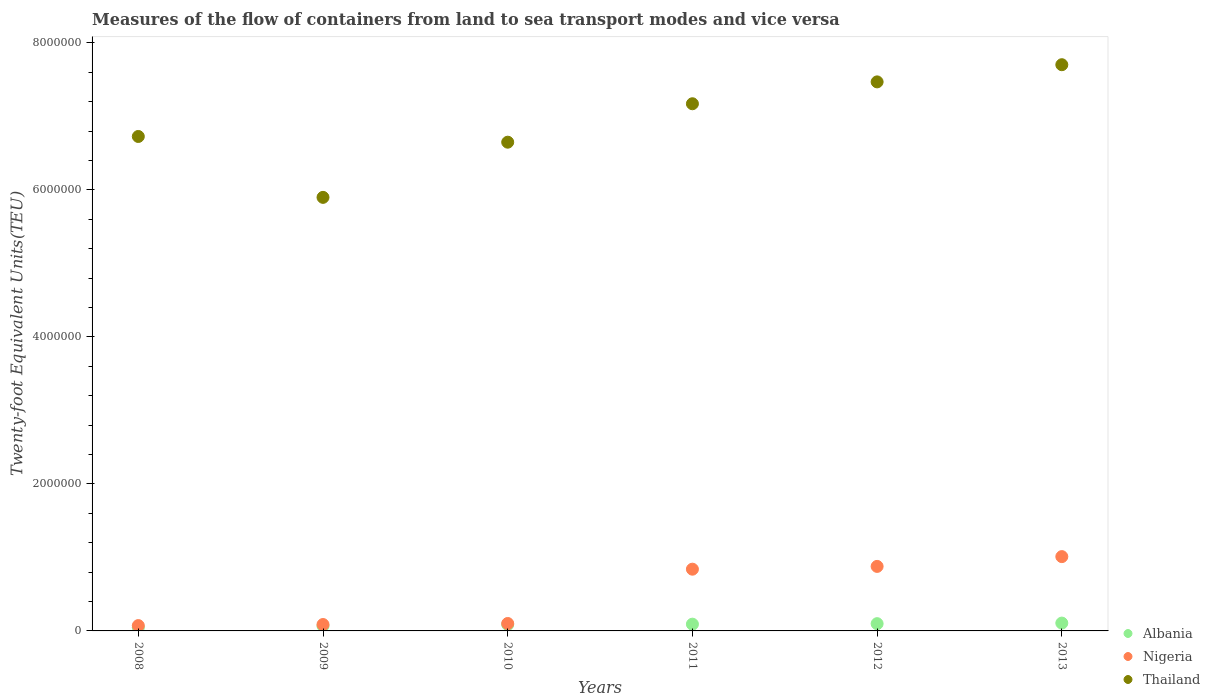How many different coloured dotlines are there?
Provide a succinct answer. 3. What is the container port traffic in Nigeria in 2010?
Keep it short and to the point. 1.01e+05. Across all years, what is the maximum container port traffic in Thailand?
Give a very brief answer. 7.70e+06. Across all years, what is the minimum container port traffic in Thailand?
Your answer should be very brief. 5.90e+06. In which year was the container port traffic in Albania maximum?
Provide a short and direct response. 2013. What is the total container port traffic in Albania in the graph?
Give a very brief answer. 5.00e+05. What is the difference between the container port traffic in Albania in 2008 and that in 2010?
Provide a short and direct response. -4.01e+04. What is the difference between the container port traffic in Thailand in 2011 and the container port traffic in Albania in 2008?
Offer a terse response. 7.12e+06. What is the average container port traffic in Thailand per year?
Offer a very short reply. 6.94e+06. In the year 2008, what is the difference between the container port traffic in Thailand and container port traffic in Albania?
Your answer should be compact. 6.68e+06. What is the ratio of the container port traffic in Albania in 2008 to that in 2012?
Give a very brief answer. 0.47. Is the difference between the container port traffic in Thailand in 2008 and 2010 greater than the difference between the container port traffic in Albania in 2008 and 2010?
Offer a very short reply. Yes. What is the difference between the highest and the second highest container port traffic in Nigeria?
Ensure brevity in your answer.  1.33e+05. What is the difference between the highest and the lowest container port traffic in Nigeria?
Your answer should be very brief. 9.38e+05. Is the sum of the container port traffic in Thailand in 2010 and 2011 greater than the maximum container port traffic in Nigeria across all years?
Your answer should be very brief. Yes. Is it the case that in every year, the sum of the container port traffic in Albania and container port traffic in Nigeria  is greater than the container port traffic in Thailand?
Offer a very short reply. No. Is the container port traffic in Nigeria strictly greater than the container port traffic in Thailand over the years?
Make the answer very short. No. How many dotlines are there?
Ensure brevity in your answer.  3. How many years are there in the graph?
Provide a short and direct response. 6. Does the graph contain any zero values?
Offer a very short reply. No. Does the graph contain grids?
Offer a very short reply. No. What is the title of the graph?
Your answer should be very brief. Measures of the flow of containers from land to sea transport modes and vice versa. What is the label or title of the X-axis?
Give a very brief answer. Years. What is the label or title of the Y-axis?
Offer a terse response. Twenty-foot Equivalent Units(TEU). What is the Twenty-foot Equivalent Units(TEU) of Albania in 2008?
Offer a very short reply. 4.68e+04. What is the Twenty-foot Equivalent Units(TEU) in Nigeria in 2008?
Provide a succinct answer. 7.25e+04. What is the Twenty-foot Equivalent Units(TEU) in Thailand in 2008?
Your answer should be very brief. 6.73e+06. What is the Twenty-foot Equivalent Units(TEU) in Albania in 2009?
Provide a succinct answer. 6.88e+04. What is the Twenty-foot Equivalent Units(TEU) of Nigeria in 2009?
Give a very brief answer. 8.70e+04. What is the Twenty-foot Equivalent Units(TEU) in Thailand in 2009?
Provide a succinct answer. 5.90e+06. What is the Twenty-foot Equivalent Units(TEU) of Albania in 2010?
Make the answer very short. 8.69e+04. What is the Twenty-foot Equivalent Units(TEU) in Nigeria in 2010?
Your response must be concise. 1.01e+05. What is the Twenty-foot Equivalent Units(TEU) in Thailand in 2010?
Ensure brevity in your answer.  6.65e+06. What is the Twenty-foot Equivalent Units(TEU) in Albania in 2011?
Your answer should be compact. 9.18e+04. What is the Twenty-foot Equivalent Units(TEU) in Nigeria in 2011?
Your answer should be very brief. 8.40e+05. What is the Twenty-foot Equivalent Units(TEU) in Thailand in 2011?
Offer a very short reply. 7.17e+06. What is the Twenty-foot Equivalent Units(TEU) in Albania in 2012?
Ensure brevity in your answer.  9.87e+04. What is the Twenty-foot Equivalent Units(TEU) in Nigeria in 2012?
Your answer should be very brief. 8.78e+05. What is the Twenty-foot Equivalent Units(TEU) of Thailand in 2012?
Your answer should be very brief. 7.47e+06. What is the Twenty-foot Equivalent Units(TEU) of Albania in 2013?
Offer a very short reply. 1.07e+05. What is the Twenty-foot Equivalent Units(TEU) in Nigeria in 2013?
Provide a succinct answer. 1.01e+06. What is the Twenty-foot Equivalent Units(TEU) in Thailand in 2013?
Ensure brevity in your answer.  7.70e+06. Across all years, what is the maximum Twenty-foot Equivalent Units(TEU) of Albania?
Offer a very short reply. 1.07e+05. Across all years, what is the maximum Twenty-foot Equivalent Units(TEU) in Nigeria?
Keep it short and to the point. 1.01e+06. Across all years, what is the maximum Twenty-foot Equivalent Units(TEU) in Thailand?
Offer a terse response. 7.70e+06. Across all years, what is the minimum Twenty-foot Equivalent Units(TEU) of Albania?
Give a very brief answer. 4.68e+04. Across all years, what is the minimum Twenty-foot Equivalent Units(TEU) of Nigeria?
Your answer should be very brief. 7.25e+04. Across all years, what is the minimum Twenty-foot Equivalent Units(TEU) of Thailand?
Your answer should be very brief. 5.90e+06. What is the total Twenty-foot Equivalent Units(TEU) of Albania in the graph?
Your answer should be compact. 5.00e+05. What is the total Twenty-foot Equivalent Units(TEU) in Nigeria in the graph?
Your answer should be compact. 2.99e+06. What is the total Twenty-foot Equivalent Units(TEU) of Thailand in the graph?
Make the answer very short. 4.16e+07. What is the difference between the Twenty-foot Equivalent Units(TEU) in Albania in 2008 and that in 2009?
Keep it short and to the point. -2.20e+04. What is the difference between the Twenty-foot Equivalent Units(TEU) in Nigeria in 2008 and that in 2009?
Give a very brief answer. -1.45e+04. What is the difference between the Twenty-foot Equivalent Units(TEU) of Thailand in 2008 and that in 2009?
Ensure brevity in your answer.  8.28e+05. What is the difference between the Twenty-foot Equivalent Units(TEU) of Albania in 2008 and that in 2010?
Make the answer very short. -4.01e+04. What is the difference between the Twenty-foot Equivalent Units(TEU) in Nigeria in 2008 and that in 2010?
Ensure brevity in your answer.  -2.85e+04. What is the difference between the Twenty-foot Equivalent Units(TEU) in Thailand in 2008 and that in 2010?
Your answer should be very brief. 7.77e+04. What is the difference between the Twenty-foot Equivalent Units(TEU) of Albania in 2008 and that in 2011?
Keep it short and to the point. -4.50e+04. What is the difference between the Twenty-foot Equivalent Units(TEU) in Nigeria in 2008 and that in 2011?
Your answer should be compact. -7.67e+05. What is the difference between the Twenty-foot Equivalent Units(TEU) in Thailand in 2008 and that in 2011?
Provide a short and direct response. -4.45e+05. What is the difference between the Twenty-foot Equivalent Units(TEU) of Albania in 2008 and that in 2012?
Provide a short and direct response. -5.19e+04. What is the difference between the Twenty-foot Equivalent Units(TEU) of Nigeria in 2008 and that in 2012?
Make the answer very short. -8.05e+05. What is the difference between the Twenty-foot Equivalent Units(TEU) of Thailand in 2008 and that in 2012?
Your answer should be compact. -7.43e+05. What is the difference between the Twenty-foot Equivalent Units(TEU) in Albania in 2008 and that in 2013?
Give a very brief answer. -5.97e+04. What is the difference between the Twenty-foot Equivalent Units(TEU) of Nigeria in 2008 and that in 2013?
Keep it short and to the point. -9.38e+05. What is the difference between the Twenty-foot Equivalent Units(TEU) of Thailand in 2008 and that in 2013?
Keep it short and to the point. -9.76e+05. What is the difference between the Twenty-foot Equivalent Units(TEU) of Albania in 2009 and that in 2010?
Provide a short and direct response. -1.81e+04. What is the difference between the Twenty-foot Equivalent Units(TEU) of Nigeria in 2009 and that in 2010?
Your answer should be compact. -1.40e+04. What is the difference between the Twenty-foot Equivalent Units(TEU) of Thailand in 2009 and that in 2010?
Provide a short and direct response. -7.51e+05. What is the difference between the Twenty-foot Equivalent Units(TEU) in Albania in 2009 and that in 2011?
Give a very brief answer. -2.30e+04. What is the difference between the Twenty-foot Equivalent Units(TEU) in Nigeria in 2009 and that in 2011?
Your answer should be very brief. -7.53e+05. What is the difference between the Twenty-foot Equivalent Units(TEU) of Thailand in 2009 and that in 2011?
Offer a very short reply. -1.27e+06. What is the difference between the Twenty-foot Equivalent Units(TEU) in Albania in 2009 and that in 2012?
Provide a succinct answer. -2.99e+04. What is the difference between the Twenty-foot Equivalent Units(TEU) of Nigeria in 2009 and that in 2012?
Your answer should be very brief. -7.91e+05. What is the difference between the Twenty-foot Equivalent Units(TEU) in Thailand in 2009 and that in 2012?
Make the answer very short. -1.57e+06. What is the difference between the Twenty-foot Equivalent Units(TEU) of Albania in 2009 and that in 2013?
Ensure brevity in your answer.  -3.77e+04. What is the difference between the Twenty-foot Equivalent Units(TEU) in Nigeria in 2009 and that in 2013?
Provide a short and direct response. -9.24e+05. What is the difference between the Twenty-foot Equivalent Units(TEU) of Thailand in 2009 and that in 2013?
Your answer should be very brief. -1.80e+06. What is the difference between the Twenty-foot Equivalent Units(TEU) in Albania in 2010 and that in 2011?
Your answer should be compact. -4951.88. What is the difference between the Twenty-foot Equivalent Units(TEU) in Nigeria in 2010 and that in 2011?
Your answer should be very brief. -7.39e+05. What is the difference between the Twenty-foot Equivalent Units(TEU) in Thailand in 2010 and that in 2011?
Ensure brevity in your answer.  -5.23e+05. What is the difference between the Twenty-foot Equivalent Units(TEU) of Albania in 2010 and that in 2012?
Your answer should be very brief. -1.18e+04. What is the difference between the Twenty-foot Equivalent Units(TEU) in Nigeria in 2010 and that in 2012?
Your response must be concise. -7.77e+05. What is the difference between the Twenty-foot Equivalent Units(TEU) in Thailand in 2010 and that in 2012?
Your response must be concise. -8.20e+05. What is the difference between the Twenty-foot Equivalent Units(TEU) of Albania in 2010 and that in 2013?
Your answer should be compact. -1.96e+04. What is the difference between the Twenty-foot Equivalent Units(TEU) in Nigeria in 2010 and that in 2013?
Offer a very short reply. -9.10e+05. What is the difference between the Twenty-foot Equivalent Units(TEU) in Thailand in 2010 and that in 2013?
Ensure brevity in your answer.  -1.05e+06. What is the difference between the Twenty-foot Equivalent Units(TEU) of Albania in 2011 and that in 2012?
Offer a terse response. -6887.02. What is the difference between the Twenty-foot Equivalent Units(TEU) in Nigeria in 2011 and that in 2012?
Keep it short and to the point. -3.78e+04. What is the difference between the Twenty-foot Equivalent Units(TEU) in Thailand in 2011 and that in 2012?
Your response must be concise. -2.98e+05. What is the difference between the Twenty-foot Equivalent Units(TEU) of Albania in 2011 and that in 2013?
Offer a very short reply. -1.47e+04. What is the difference between the Twenty-foot Equivalent Units(TEU) of Nigeria in 2011 and that in 2013?
Your answer should be very brief. -1.71e+05. What is the difference between the Twenty-foot Equivalent Units(TEU) in Thailand in 2011 and that in 2013?
Provide a short and direct response. -5.31e+05. What is the difference between the Twenty-foot Equivalent Units(TEU) in Albania in 2012 and that in 2013?
Provide a succinct answer. -7798.4. What is the difference between the Twenty-foot Equivalent Units(TEU) in Nigeria in 2012 and that in 2013?
Provide a short and direct response. -1.33e+05. What is the difference between the Twenty-foot Equivalent Units(TEU) in Thailand in 2012 and that in 2013?
Provide a succinct answer. -2.34e+05. What is the difference between the Twenty-foot Equivalent Units(TEU) in Albania in 2008 and the Twenty-foot Equivalent Units(TEU) in Nigeria in 2009?
Give a very brief answer. -4.02e+04. What is the difference between the Twenty-foot Equivalent Units(TEU) of Albania in 2008 and the Twenty-foot Equivalent Units(TEU) of Thailand in 2009?
Provide a succinct answer. -5.85e+06. What is the difference between the Twenty-foot Equivalent Units(TEU) in Nigeria in 2008 and the Twenty-foot Equivalent Units(TEU) in Thailand in 2009?
Your response must be concise. -5.83e+06. What is the difference between the Twenty-foot Equivalent Units(TEU) in Albania in 2008 and the Twenty-foot Equivalent Units(TEU) in Nigeria in 2010?
Provide a succinct answer. -5.42e+04. What is the difference between the Twenty-foot Equivalent Units(TEU) in Albania in 2008 and the Twenty-foot Equivalent Units(TEU) in Thailand in 2010?
Your answer should be very brief. -6.60e+06. What is the difference between the Twenty-foot Equivalent Units(TEU) in Nigeria in 2008 and the Twenty-foot Equivalent Units(TEU) in Thailand in 2010?
Offer a terse response. -6.58e+06. What is the difference between the Twenty-foot Equivalent Units(TEU) in Albania in 2008 and the Twenty-foot Equivalent Units(TEU) in Nigeria in 2011?
Provide a short and direct response. -7.93e+05. What is the difference between the Twenty-foot Equivalent Units(TEU) in Albania in 2008 and the Twenty-foot Equivalent Units(TEU) in Thailand in 2011?
Make the answer very short. -7.12e+06. What is the difference between the Twenty-foot Equivalent Units(TEU) of Nigeria in 2008 and the Twenty-foot Equivalent Units(TEU) of Thailand in 2011?
Your response must be concise. -7.10e+06. What is the difference between the Twenty-foot Equivalent Units(TEU) in Albania in 2008 and the Twenty-foot Equivalent Units(TEU) in Nigeria in 2012?
Your answer should be compact. -8.31e+05. What is the difference between the Twenty-foot Equivalent Units(TEU) of Albania in 2008 and the Twenty-foot Equivalent Units(TEU) of Thailand in 2012?
Your answer should be very brief. -7.42e+06. What is the difference between the Twenty-foot Equivalent Units(TEU) of Nigeria in 2008 and the Twenty-foot Equivalent Units(TEU) of Thailand in 2012?
Offer a terse response. -7.40e+06. What is the difference between the Twenty-foot Equivalent Units(TEU) of Albania in 2008 and the Twenty-foot Equivalent Units(TEU) of Nigeria in 2013?
Your answer should be very brief. -9.64e+05. What is the difference between the Twenty-foot Equivalent Units(TEU) in Albania in 2008 and the Twenty-foot Equivalent Units(TEU) in Thailand in 2013?
Make the answer very short. -7.66e+06. What is the difference between the Twenty-foot Equivalent Units(TEU) in Nigeria in 2008 and the Twenty-foot Equivalent Units(TEU) in Thailand in 2013?
Give a very brief answer. -7.63e+06. What is the difference between the Twenty-foot Equivalent Units(TEU) in Albania in 2009 and the Twenty-foot Equivalent Units(TEU) in Nigeria in 2010?
Give a very brief answer. -3.22e+04. What is the difference between the Twenty-foot Equivalent Units(TEU) in Albania in 2009 and the Twenty-foot Equivalent Units(TEU) in Thailand in 2010?
Offer a terse response. -6.58e+06. What is the difference between the Twenty-foot Equivalent Units(TEU) of Nigeria in 2009 and the Twenty-foot Equivalent Units(TEU) of Thailand in 2010?
Offer a terse response. -6.56e+06. What is the difference between the Twenty-foot Equivalent Units(TEU) in Albania in 2009 and the Twenty-foot Equivalent Units(TEU) in Nigeria in 2011?
Keep it short and to the point. -7.71e+05. What is the difference between the Twenty-foot Equivalent Units(TEU) in Albania in 2009 and the Twenty-foot Equivalent Units(TEU) in Thailand in 2011?
Offer a terse response. -7.10e+06. What is the difference between the Twenty-foot Equivalent Units(TEU) of Nigeria in 2009 and the Twenty-foot Equivalent Units(TEU) of Thailand in 2011?
Your answer should be compact. -7.08e+06. What is the difference between the Twenty-foot Equivalent Units(TEU) in Albania in 2009 and the Twenty-foot Equivalent Units(TEU) in Nigeria in 2012?
Provide a short and direct response. -8.09e+05. What is the difference between the Twenty-foot Equivalent Units(TEU) of Albania in 2009 and the Twenty-foot Equivalent Units(TEU) of Thailand in 2012?
Offer a very short reply. -7.40e+06. What is the difference between the Twenty-foot Equivalent Units(TEU) in Nigeria in 2009 and the Twenty-foot Equivalent Units(TEU) in Thailand in 2012?
Provide a succinct answer. -7.38e+06. What is the difference between the Twenty-foot Equivalent Units(TEU) of Albania in 2009 and the Twenty-foot Equivalent Units(TEU) of Nigeria in 2013?
Provide a succinct answer. -9.42e+05. What is the difference between the Twenty-foot Equivalent Units(TEU) of Albania in 2009 and the Twenty-foot Equivalent Units(TEU) of Thailand in 2013?
Offer a terse response. -7.63e+06. What is the difference between the Twenty-foot Equivalent Units(TEU) of Nigeria in 2009 and the Twenty-foot Equivalent Units(TEU) of Thailand in 2013?
Your answer should be compact. -7.62e+06. What is the difference between the Twenty-foot Equivalent Units(TEU) of Albania in 2010 and the Twenty-foot Equivalent Units(TEU) of Nigeria in 2011?
Offer a very short reply. -7.53e+05. What is the difference between the Twenty-foot Equivalent Units(TEU) of Albania in 2010 and the Twenty-foot Equivalent Units(TEU) of Thailand in 2011?
Offer a terse response. -7.08e+06. What is the difference between the Twenty-foot Equivalent Units(TEU) in Nigeria in 2010 and the Twenty-foot Equivalent Units(TEU) in Thailand in 2011?
Keep it short and to the point. -7.07e+06. What is the difference between the Twenty-foot Equivalent Units(TEU) of Albania in 2010 and the Twenty-foot Equivalent Units(TEU) of Nigeria in 2012?
Keep it short and to the point. -7.91e+05. What is the difference between the Twenty-foot Equivalent Units(TEU) in Albania in 2010 and the Twenty-foot Equivalent Units(TEU) in Thailand in 2012?
Provide a short and direct response. -7.38e+06. What is the difference between the Twenty-foot Equivalent Units(TEU) in Nigeria in 2010 and the Twenty-foot Equivalent Units(TEU) in Thailand in 2012?
Offer a very short reply. -7.37e+06. What is the difference between the Twenty-foot Equivalent Units(TEU) in Albania in 2010 and the Twenty-foot Equivalent Units(TEU) in Nigeria in 2013?
Give a very brief answer. -9.24e+05. What is the difference between the Twenty-foot Equivalent Units(TEU) of Albania in 2010 and the Twenty-foot Equivalent Units(TEU) of Thailand in 2013?
Make the answer very short. -7.62e+06. What is the difference between the Twenty-foot Equivalent Units(TEU) of Nigeria in 2010 and the Twenty-foot Equivalent Units(TEU) of Thailand in 2013?
Make the answer very short. -7.60e+06. What is the difference between the Twenty-foot Equivalent Units(TEU) in Albania in 2011 and the Twenty-foot Equivalent Units(TEU) in Nigeria in 2012?
Give a very brief answer. -7.86e+05. What is the difference between the Twenty-foot Equivalent Units(TEU) in Albania in 2011 and the Twenty-foot Equivalent Units(TEU) in Thailand in 2012?
Offer a very short reply. -7.38e+06. What is the difference between the Twenty-foot Equivalent Units(TEU) of Nigeria in 2011 and the Twenty-foot Equivalent Units(TEU) of Thailand in 2012?
Make the answer very short. -6.63e+06. What is the difference between the Twenty-foot Equivalent Units(TEU) in Albania in 2011 and the Twenty-foot Equivalent Units(TEU) in Nigeria in 2013?
Your answer should be very brief. -9.19e+05. What is the difference between the Twenty-foot Equivalent Units(TEU) of Albania in 2011 and the Twenty-foot Equivalent Units(TEU) of Thailand in 2013?
Make the answer very short. -7.61e+06. What is the difference between the Twenty-foot Equivalent Units(TEU) in Nigeria in 2011 and the Twenty-foot Equivalent Units(TEU) in Thailand in 2013?
Offer a terse response. -6.86e+06. What is the difference between the Twenty-foot Equivalent Units(TEU) in Albania in 2012 and the Twenty-foot Equivalent Units(TEU) in Nigeria in 2013?
Make the answer very short. -9.12e+05. What is the difference between the Twenty-foot Equivalent Units(TEU) of Albania in 2012 and the Twenty-foot Equivalent Units(TEU) of Thailand in 2013?
Provide a short and direct response. -7.60e+06. What is the difference between the Twenty-foot Equivalent Units(TEU) in Nigeria in 2012 and the Twenty-foot Equivalent Units(TEU) in Thailand in 2013?
Provide a succinct answer. -6.82e+06. What is the average Twenty-foot Equivalent Units(TEU) of Albania per year?
Offer a very short reply. 8.33e+04. What is the average Twenty-foot Equivalent Units(TEU) in Nigeria per year?
Give a very brief answer. 4.98e+05. What is the average Twenty-foot Equivalent Units(TEU) of Thailand per year?
Give a very brief answer. 6.94e+06. In the year 2008, what is the difference between the Twenty-foot Equivalent Units(TEU) of Albania and Twenty-foot Equivalent Units(TEU) of Nigeria?
Offer a very short reply. -2.57e+04. In the year 2008, what is the difference between the Twenty-foot Equivalent Units(TEU) in Albania and Twenty-foot Equivalent Units(TEU) in Thailand?
Offer a very short reply. -6.68e+06. In the year 2008, what is the difference between the Twenty-foot Equivalent Units(TEU) in Nigeria and Twenty-foot Equivalent Units(TEU) in Thailand?
Keep it short and to the point. -6.65e+06. In the year 2009, what is the difference between the Twenty-foot Equivalent Units(TEU) in Albania and Twenty-foot Equivalent Units(TEU) in Nigeria?
Your response must be concise. -1.82e+04. In the year 2009, what is the difference between the Twenty-foot Equivalent Units(TEU) of Albania and Twenty-foot Equivalent Units(TEU) of Thailand?
Offer a terse response. -5.83e+06. In the year 2009, what is the difference between the Twenty-foot Equivalent Units(TEU) of Nigeria and Twenty-foot Equivalent Units(TEU) of Thailand?
Give a very brief answer. -5.81e+06. In the year 2010, what is the difference between the Twenty-foot Equivalent Units(TEU) in Albania and Twenty-foot Equivalent Units(TEU) in Nigeria?
Your answer should be very brief. -1.41e+04. In the year 2010, what is the difference between the Twenty-foot Equivalent Units(TEU) in Albania and Twenty-foot Equivalent Units(TEU) in Thailand?
Offer a terse response. -6.56e+06. In the year 2010, what is the difference between the Twenty-foot Equivalent Units(TEU) of Nigeria and Twenty-foot Equivalent Units(TEU) of Thailand?
Your answer should be compact. -6.55e+06. In the year 2011, what is the difference between the Twenty-foot Equivalent Units(TEU) in Albania and Twenty-foot Equivalent Units(TEU) in Nigeria?
Your response must be concise. -7.48e+05. In the year 2011, what is the difference between the Twenty-foot Equivalent Units(TEU) in Albania and Twenty-foot Equivalent Units(TEU) in Thailand?
Offer a terse response. -7.08e+06. In the year 2011, what is the difference between the Twenty-foot Equivalent Units(TEU) of Nigeria and Twenty-foot Equivalent Units(TEU) of Thailand?
Provide a short and direct response. -6.33e+06. In the year 2012, what is the difference between the Twenty-foot Equivalent Units(TEU) in Albania and Twenty-foot Equivalent Units(TEU) in Nigeria?
Provide a short and direct response. -7.79e+05. In the year 2012, what is the difference between the Twenty-foot Equivalent Units(TEU) in Albania and Twenty-foot Equivalent Units(TEU) in Thailand?
Give a very brief answer. -7.37e+06. In the year 2012, what is the difference between the Twenty-foot Equivalent Units(TEU) of Nigeria and Twenty-foot Equivalent Units(TEU) of Thailand?
Offer a terse response. -6.59e+06. In the year 2013, what is the difference between the Twenty-foot Equivalent Units(TEU) of Albania and Twenty-foot Equivalent Units(TEU) of Nigeria?
Keep it short and to the point. -9.04e+05. In the year 2013, what is the difference between the Twenty-foot Equivalent Units(TEU) in Albania and Twenty-foot Equivalent Units(TEU) in Thailand?
Keep it short and to the point. -7.60e+06. In the year 2013, what is the difference between the Twenty-foot Equivalent Units(TEU) in Nigeria and Twenty-foot Equivalent Units(TEU) in Thailand?
Ensure brevity in your answer.  -6.69e+06. What is the ratio of the Twenty-foot Equivalent Units(TEU) of Albania in 2008 to that in 2009?
Make the answer very short. 0.68. What is the ratio of the Twenty-foot Equivalent Units(TEU) in Thailand in 2008 to that in 2009?
Offer a terse response. 1.14. What is the ratio of the Twenty-foot Equivalent Units(TEU) in Albania in 2008 to that in 2010?
Your answer should be compact. 0.54. What is the ratio of the Twenty-foot Equivalent Units(TEU) in Nigeria in 2008 to that in 2010?
Offer a terse response. 0.72. What is the ratio of the Twenty-foot Equivalent Units(TEU) of Thailand in 2008 to that in 2010?
Ensure brevity in your answer.  1.01. What is the ratio of the Twenty-foot Equivalent Units(TEU) in Albania in 2008 to that in 2011?
Provide a short and direct response. 0.51. What is the ratio of the Twenty-foot Equivalent Units(TEU) in Nigeria in 2008 to that in 2011?
Your response must be concise. 0.09. What is the ratio of the Twenty-foot Equivalent Units(TEU) of Thailand in 2008 to that in 2011?
Make the answer very short. 0.94. What is the ratio of the Twenty-foot Equivalent Units(TEU) of Albania in 2008 to that in 2012?
Make the answer very short. 0.47. What is the ratio of the Twenty-foot Equivalent Units(TEU) in Nigeria in 2008 to that in 2012?
Offer a very short reply. 0.08. What is the ratio of the Twenty-foot Equivalent Units(TEU) in Thailand in 2008 to that in 2012?
Make the answer very short. 0.9. What is the ratio of the Twenty-foot Equivalent Units(TEU) in Albania in 2008 to that in 2013?
Your response must be concise. 0.44. What is the ratio of the Twenty-foot Equivalent Units(TEU) in Nigeria in 2008 to that in 2013?
Make the answer very short. 0.07. What is the ratio of the Twenty-foot Equivalent Units(TEU) of Thailand in 2008 to that in 2013?
Offer a very short reply. 0.87. What is the ratio of the Twenty-foot Equivalent Units(TEU) of Albania in 2009 to that in 2010?
Offer a very short reply. 0.79. What is the ratio of the Twenty-foot Equivalent Units(TEU) of Nigeria in 2009 to that in 2010?
Provide a succinct answer. 0.86. What is the ratio of the Twenty-foot Equivalent Units(TEU) of Thailand in 2009 to that in 2010?
Give a very brief answer. 0.89. What is the ratio of the Twenty-foot Equivalent Units(TEU) of Albania in 2009 to that in 2011?
Offer a terse response. 0.75. What is the ratio of the Twenty-foot Equivalent Units(TEU) of Nigeria in 2009 to that in 2011?
Your response must be concise. 0.1. What is the ratio of the Twenty-foot Equivalent Units(TEU) of Thailand in 2009 to that in 2011?
Give a very brief answer. 0.82. What is the ratio of the Twenty-foot Equivalent Units(TEU) in Albania in 2009 to that in 2012?
Your answer should be compact. 0.7. What is the ratio of the Twenty-foot Equivalent Units(TEU) of Nigeria in 2009 to that in 2012?
Provide a short and direct response. 0.1. What is the ratio of the Twenty-foot Equivalent Units(TEU) of Thailand in 2009 to that in 2012?
Your answer should be compact. 0.79. What is the ratio of the Twenty-foot Equivalent Units(TEU) of Albania in 2009 to that in 2013?
Provide a succinct answer. 0.65. What is the ratio of the Twenty-foot Equivalent Units(TEU) in Nigeria in 2009 to that in 2013?
Make the answer very short. 0.09. What is the ratio of the Twenty-foot Equivalent Units(TEU) of Thailand in 2009 to that in 2013?
Offer a very short reply. 0.77. What is the ratio of the Twenty-foot Equivalent Units(TEU) of Albania in 2010 to that in 2011?
Your response must be concise. 0.95. What is the ratio of the Twenty-foot Equivalent Units(TEU) in Nigeria in 2010 to that in 2011?
Your answer should be compact. 0.12. What is the ratio of the Twenty-foot Equivalent Units(TEU) in Thailand in 2010 to that in 2011?
Your response must be concise. 0.93. What is the ratio of the Twenty-foot Equivalent Units(TEU) of Albania in 2010 to that in 2012?
Your answer should be compact. 0.88. What is the ratio of the Twenty-foot Equivalent Units(TEU) of Nigeria in 2010 to that in 2012?
Offer a terse response. 0.12. What is the ratio of the Twenty-foot Equivalent Units(TEU) of Thailand in 2010 to that in 2012?
Offer a terse response. 0.89. What is the ratio of the Twenty-foot Equivalent Units(TEU) in Albania in 2010 to that in 2013?
Keep it short and to the point. 0.82. What is the ratio of the Twenty-foot Equivalent Units(TEU) of Nigeria in 2010 to that in 2013?
Give a very brief answer. 0.1. What is the ratio of the Twenty-foot Equivalent Units(TEU) in Thailand in 2010 to that in 2013?
Your answer should be very brief. 0.86. What is the ratio of the Twenty-foot Equivalent Units(TEU) in Albania in 2011 to that in 2012?
Your answer should be compact. 0.93. What is the ratio of the Twenty-foot Equivalent Units(TEU) of Thailand in 2011 to that in 2012?
Provide a succinct answer. 0.96. What is the ratio of the Twenty-foot Equivalent Units(TEU) of Albania in 2011 to that in 2013?
Your response must be concise. 0.86. What is the ratio of the Twenty-foot Equivalent Units(TEU) of Nigeria in 2011 to that in 2013?
Give a very brief answer. 0.83. What is the ratio of the Twenty-foot Equivalent Units(TEU) of Thailand in 2011 to that in 2013?
Provide a succinct answer. 0.93. What is the ratio of the Twenty-foot Equivalent Units(TEU) of Albania in 2012 to that in 2013?
Offer a terse response. 0.93. What is the ratio of the Twenty-foot Equivalent Units(TEU) in Nigeria in 2012 to that in 2013?
Your answer should be very brief. 0.87. What is the ratio of the Twenty-foot Equivalent Units(TEU) in Thailand in 2012 to that in 2013?
Your answer should be compact. 0.97. What is the difference between the highest and the second highest Twenty-foot Equivalent Units(TEU) of Albania?
Give a very brief answer. 7798.4. What is the difference between the highest and the second highest Twenty-foot Equivalent Units(TEU) of Nigeria?
Your response must be concise. 1.33e+05. What is the difference between the highest and the second highest Twenty-foot Equivalent Units(TEU) of Thailand?
Keep it short and to the point. 2.34e+05. What is the difference between the highest and the lowest Twenty-foot Equivalent Units(TEU) in Albania?
Offer a terse response. 5.97e+04. What is the difference between the highest and the lowest Twenty-foot Equivalent Units(TEU) in Nigeria?
Make the answer very short. 9.38e+05. What is the difference between the highest and the lowest Twenty-foot Equivalent Units(TEU) of Thailand?
Give a very brief answer. 1.80e+06. 